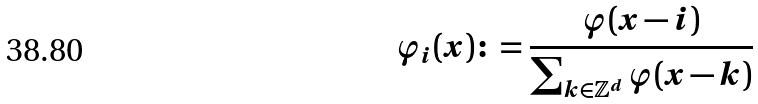Convert formula to latex. <formula><loc_0><loc_0><loc_500><loc_500>\varphi _ { i } ( x ) \colon = \frac { \varphi ( x - i ) } { \sum _ { k \in \mathbb { Z } ^ { d } } \varphi ( x - k ) }</formula> 